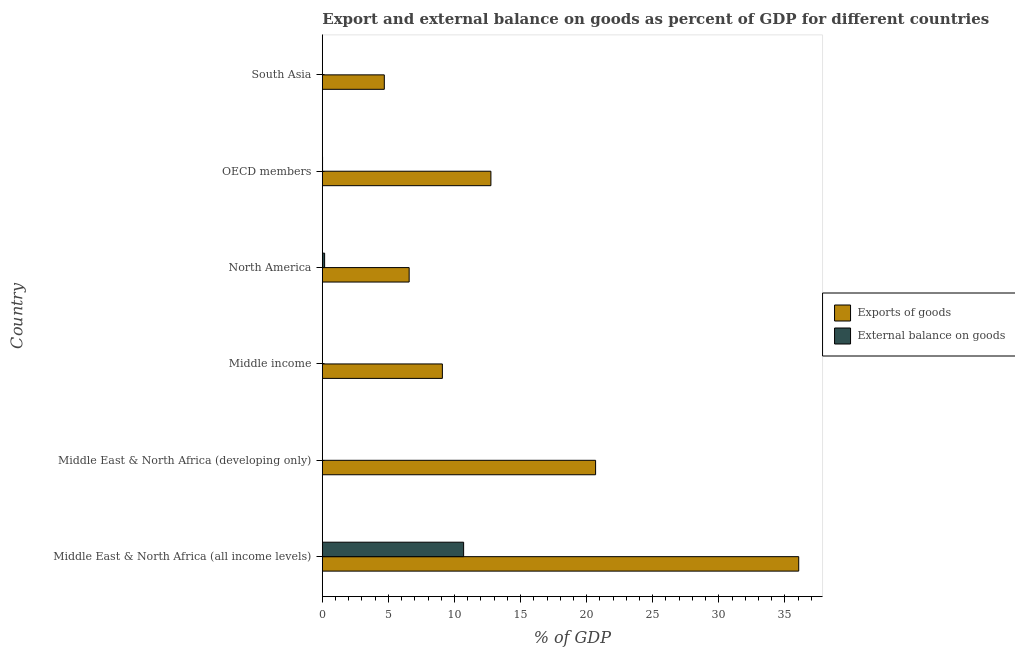How many bars are there on the 6th tick from the top?
Provide a short and direct response. 2. What is the label of the 3rd group of bars from the top?
Give a very brief answer. North America. What is the external balance on goods as percentage of gdp in OECD members?
Ensure brevity in your answer.  0.02. Across all countries, what is the maximum export of goods as percentage of gdp?
Your answer should be compact. 36.04. In which country was the export of goods as percentage of gdp maximum?
Your answer should be very brief. Middle East & North Africa (all income levels). What is the total export of goods as percentage of gdp in the graph?
Your answer should be very brief. 89.81. What is the difference between the export of goods as percentage of gdp in Middle East & North Africa (all income levels) and that in OECD members?
Provide a short and direct response. 23.29. What is the difference between the external balance on goods as percentage of gdp in South Asia and the export of goods as percentage of gdp in Middle East & North Africa (all income levels)?
Your answer should be compact. -36.04. What is the average export of goods as percentage of gdp per country?
Give a very brief answer. 14.97. What is the difference between the external balance on goods as percentage of gdp and export of goods as percentage of gdp in Middle East & North Africa (all income levels)?
Offer a very short reply. -25.35. What is the ratio of the external balance on goods as percentage of gdp in Middle East & North Africa (all income levels) to that in North America?
Ensure brevity in your answer.  61.45. Is the export of goods as percentage of gdp in Middle income less than that in South Asia?
Your response must be concise. No. Is the difference between the external balance on goods as percentage of gdp in North America and OECD members greater than the difference between the export of goods as percentage of gdp in North America and OECD members?
Provide a succinct answer. Yes. What is the difference between the highest and the second highest export of goods as percentage of gdp?
Give a very brief answer. 15.37. What is the difference between the highest and the lowest export of goods as percentage of gdp?
Offer a very short reply. 31.35. Is the sum of the external balance on goods as percentage of gdp in North America and OECD members greater than the maximum export of goods as percentage of gdp across all countries?
Provide a succinct answer. No. How many bars are there?
Provide a succinct answer. 9. Are all the bars in the graph horizontal?
Provide a succinct answer. Yes. How many countries are there in the graph?
Your answer should be compact. 6. Does the graph contain any zero values?
Keep it short and to the point. Yes. Does the graph contain grids?
Offer a terse response. No. Where does the legend appear in the graph?
Offer a very short reply. Center right. How many legend labels are there?
Your answer should be compact. 2. What is the title of the graph?
Keep it short and to the point. Export and external balance on goods as percent of GDP for different countries. What is the label or title of the X-axis?
Offer a terse response. % of GDP. What is the % of GDP in Exports of goods in Middle East & North Africa (all income levels)?
Your response must be concise. 36.04. What is the % of GDP in External balance on goods in Middle East & North Africa (all income levels)?
Provide a succinct answer. 10.69. What is the % of GDP in Exports of goods in Middle East & North Africa (developing only)?
Offer a very short reply. 20.68. What is the % of GDP in External balance on goods in Middle East & North Africa (developing only)?
Provide a short and direct response. 0. What is the % of GDP of Exports of goods in Middle income?
Offer a very short reply. 9.08. What is the % of GDP in External balance on goods in Middle income?
Give a very brief answer. 0. What is the % of GDP in Exports of goods in North America?
Provide a succinct answer. 6.57. What is the % of GDP in External balance on goods in North America?
Your response must be concise. 0.17. What is the % of GDP in Exports of goods in OECD members?
Offer a very short reply. 12.75. What is the % of GDP in External balance on goods in OECD members?
Give a very brief answer. 0.02. What is the % of GDP in Exports of goods in South Asia?
Give a very brief answer. 4.69. Across all countries, what is the maximum % of GDP in Exports of goods?
Your response must be concise. 36.04. Across all countries, what is the maximum % of GDP of External balance on goods?
Your answer should be compact. 10.69. Across all countries, what is the minimum % of GDP in Exports of goods?
Make the answer very short. 4.69. Across all countries, what is the minimum % of GDP of External balance on goods?
Offer a very short reply. 0. What is the total % of GDP of Exports of goods in the graph?
Provide a short and direct response. 89.81. What is the total % of GDP in External balance on goods in the graph?
Make the answer very short. 10.88. What is the difference between the % of GDP of Exports of goods in Middle East & North Africa (all income levels) and that in Middle East & North Africa (developing only)?
Your answer should be compact. 15.37. What is the difference between the % of GDP in Exports of goods in Middle East & North Africa (all income levels) and that in Middle income?
Make the answer very short. 26.96. What is the difference between the % of GDP in Exports of goods in Middle East & North Africa (all income levels) and that in North America?
Your response must be concise. 29.47. What is the difference between the % of GDP of External balance on goods in Middle East & North Africa (all income levels) and that in North America?
Offer a terse response. 10.52. What is the difference between the % of GDP of Exports of goods in Middle East & North Africa (all income levels) and that in OECD members?
Your answer should be very brief. 23.29. What is the difference between the % of GDP in External balance on goods in Middle East & North Africa (all income levels) and that in OECD members?
Offer a terse response. 10.67. What is the difference between the % of GDP of Exports of goods in Middle East & North Africa (all income levels) and that in South Asia?
Ensure brevity in your answer.  31.35. What is the difference between the % of GDP of Exports of goods in Middle East & North Africa (developing only) and that in Middle income?
Your response must be concise. 11.59. What is the difference between the % of GDP of Exports of goods in Middle East & North Africa (developing only) and that in North America?
Ensure brevity in your answer.  14.11. What is the difference between the % of GDP of Exports of goods in Middle East & North Africa (developing only) and that in OECD members?
Offer a terse response. 7.92. What is the difference between the % of GDP of Exports of goods in Middle East & North Africa (developing only) and that in South Asia?
Provide a succinct answer. 15.99. What is the difference between the % of GDP of Exports of goods in Middle income and that in North America?
Your response must be concise. 2.51. What is the difference between the % of GDP in Exports of goods in Middle income and that in OECD members?
Keep it short and to the point. -3.67. What is the difference between the % of GDP of Exports of goods in Middle income and that in South Asia?
Provide a succinct answer. 4.39. What is the difference between the % of GDP of Exports of goods in North America and that in OECD members?
Provide a short and direct response. -6.18. What is the difference between the % of GDP in External balance on goods in North America and that in OECD members?
Provide a succinct answer. 0.16. What is the difference between the % of GDP in Exports of goods in North America and that in South Asia?
Provide a succinct answer. 1.88. What is the difference between the % of GDP in Exports of goods in OECD members and that in South Asia?
Your answer should be very brief. 8.07. What is the difference between the % of GDP in Exports of goods in Middle East & North Africa (all income levels) and the % of GDP in External balance on goods in North America?
Your answer should be compact. 35.87. What is the difference between the % of GDP of Exports of goods in Middle East & North Africa (all income levels) and the % of GDP of External balance on goods in OECD members?
Provide a succinct answer. 36.03. What is the difference between the % of GDP in Exports of goods in Middle East & North Africa (developing only) and the % of GDP in External balance on goods in North America?
Your response must be concise. 20.5. What is the difference between the % of GDP in Exports of goods in Middle East & North Africa (developing only) and the % of GDP in External balance on goods in OECD members?
Give a very brief answer. 20.66. What is the difference between the % of GDP of Exports of goods in Middle income and the % of GDP of External balance on goods in North America?
Your response must be concise. 8.91. What is the difference between the % of GDP of Exports of goods in Middle income and the % of GDP of External balance on goods in OECD members?
Offer a very short reply. 9.07. What is the difference between the % of GDP of Exports of goods in North America and the % of GDP of External balance on goods in OECD members?
Give a very brief answer. 6.55. What is the average % of GDP of Exports of goods per country?
Provide a succinct answer. 14.97. What is the average % of GDP of External balance on goods per country?
Keep it short and to the point. 1.81. What is the difference between the % of GDP in Exports of goods and % of GDP in External balance on goods in Middle East & North Africa (all income levels)?
Provide a succinct answer. 25.35. What is the difference between the % of GDP of Exports of goods and % of GDP of External balance on goods in North America?
Keep it short and to the point. 6.4. What is the difference between the % of GDP in Exports of goods and % of GDP in External balance on goods in OECD members?
Keep it short and to the point. 12.74. What is the ratio of the % of GDP in Exports of goods in Middle East & North Africa (all income levels) to that in Middle East & North Africa (developing only)?
Offer a very short reply. 1.74. What is the ratio of the % of GDP of Exports of goods in Middle East & North Africa (all income levels) to that in Middle income?
Offer a very short reply. 3.97. What is the ratio of the % of GDP of Exports of goods in Middle East & North Africa (all income levels) to that in North America?
Make the answer very short. 5.49. What is the ratio of the % of GDP of External balance on goods in Middle East & North Africa (all income levels) to that in North America?
Keep it short and to the point. 61.45. What is the ratio of the % of GDP in Exports of goods in Middle East & North Africa (all income levels) to that in OECD members?
Offer a terse response. 2.83. What is the ratio of the % of GDP of External balance on goods in Middle East & North Africa (all income levels) to that in OECD members?
Offer a terse response. 658.79. What is the ratio of the % of GDP in Exports of goods in Middle East & North Africa (all income levels) to that in South Asia?
Your answer should be very brief. 7.69. What is the ratio of the % of GDP of Exports of goods in Middle East & North Africa (developing only) to that in Middle income?
Offer a very short reply. 2.28. What is the ratio of the % of GDP in Exports of goods in Middle East & North Africa (developing only) to that in North America?
Your response must be concise. 3.15. What is the ratio of the % of GDP of Exports of goods in Middle East & North Africa (developing only) to that in OECD members?
Offer a terse response. 1.62. What is the ratio of the % of GDP in Exports of goods in Middle East & North Africa (developing only) to that in South Asia?
Your response must be concise. 4.41. What is the ratio of the % of GDP of Exports of goods in Middle income to that in North America?
Make the answer very short. 1.38. What is the ratio of the % of GDP in Exports of goods in Middle income to that in OECD members?
Provide a succinct answer. 0.71. What is the ratio of the % of GDP of Exports of goods in Middle income to that in South Asia?
Your answer should be very brief. 1.94. What is the ratio of the % of GDP of Exports of goods in North America to that in OECD members?
Give a very brief answer. 0.52. What is the ratio of the % of GDP in External balance on goods in North America to that in OECD members?
Keep it short and to the point. 10.72. What is the ratio of the % of GDP in Exports of goods in North America to that in South Asia?
Offer a terse response. 1.4. What is the ratio of the % of GDP in Exports of goods in OECD members to that in South Asia?
Keep it short and to the point. 2.72. What is the difference between the highest and the second highest % of GDP of Exports of goods?
Keep it short and to the point. 15.37. What is the difference between the highest and the second highest % of GDP in External balance on goods?
Give a very brief answer. 10.52. What is the difference between the highest and the lowest % of GDP in Exports of goods?
Offer a very short reply. 31.35. What is the difference between the highest and the lowest % of GDP of External balance on goods?
Give a very brief answer. 10.69. 